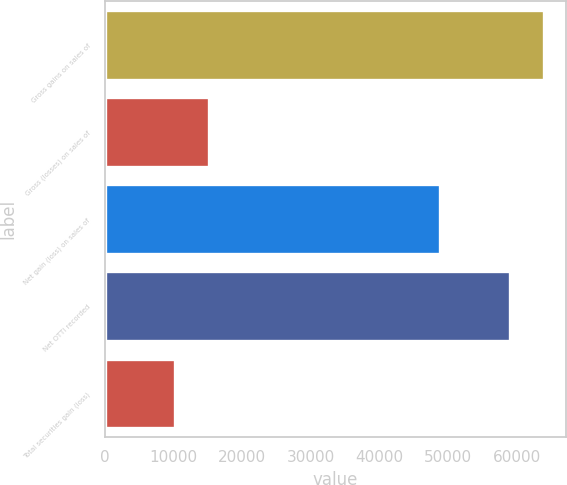<chart> <loc_0><loc_0><loc_500><loc_500><bar_chart><fcel>Gross gains on sales of<fcel>Gross (losses) on sales of<fcel>Net gain (loss) on sales of<fcel>Net OTTI recorded<fcel>Total securities gain (loss)<nl><fcel>64015.3<fcel>15200.3<fcel>48815<fcel>59064<fcel>10249<nl></chart> 